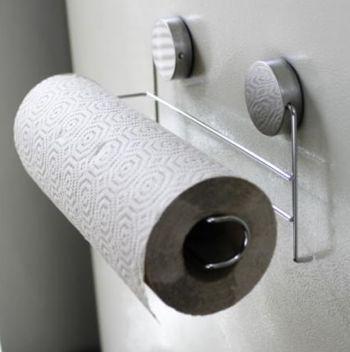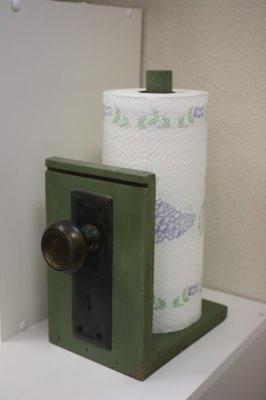The first image is the image on the left, the second image is the image on the right. Analyze the images presented: Is the assertion "An image shows one towel row mounted horizontally, with a sheet hanging toward the left." valid? Answer yes or no. Yes. The first image is the image on the left, the second image is the image on the right. For the images displayed, is the sentence "In one image, a roll of paper towels is attached to a chrome hanging towel holder, while a second image shows a roll of paper towels on an upright towel holder." factually correct? Answer yes or no. Yes. 